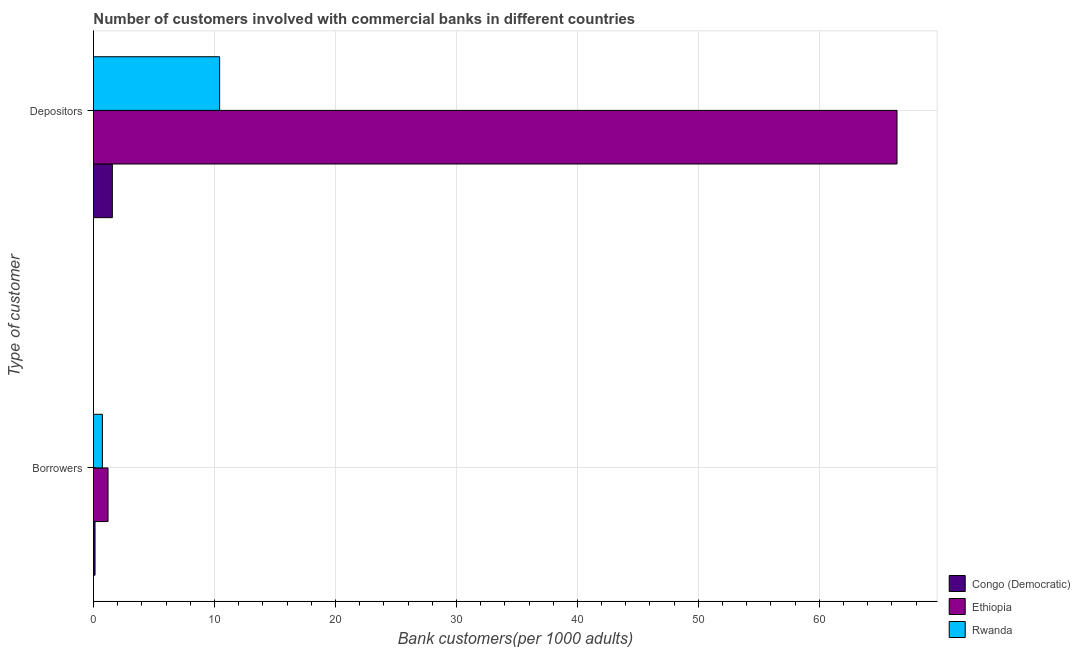How many different coloured bars are there?
Your response must be concise. 3. How many groups of bars are there?
Provide a short and direct response. 2. How many bars are there on the 2nd tick from the top?
Your answer should be compact. 3. What is the label of the 1st group of bars from the top?
Provide a succinct answer. Depositors. What is the number of depositors in Rwanda?
Your answer should be very brief. 10.43. Across all countries, what is the maximum number of depositors?
Your answer should be very brief. 66.42. Across all countries, what is the minimum number of borrowers?
Your answer should be very brief. 0.13. In which country was the number of depositors maximum?
Give a very brief answer. Ethiopia. In which country was the number of depositors minimum?
Your answer should be compact. Congo (Democratic). What is the total number of borrowers in the graph?
Your response must be concise. 2.07. What is the difference between the number of depositors in Ethiopia and that in Congo (Democratic)?
Make the answer very short. 64.86. What is the difference between the number of borrowers in Ethiopia and the number of depositors in Rwanda?
Give a very brief answer. -9.22. What is the average number of depositors per country?
Give a very brief answer. 26.14. What is the difference between the number of depositors and number of borrowers in Ethiopia?
Give a very brief answer. 65.21. What is the ratio of the number of depositors in Rwanda to that in Congo (Democratic)?
Your response must be concise. 6.68. Is the number of borrowers in Ethiopia less than that in Rwanda?
Offer a terse response. No. What does the 3rd bar from the top in Depositors represents?
Provide a short and direct response. Congo (Democratic). What does the 3rd bar from the bottom in Depositors represents?
Your answer should be compact. Rwanda. How many bars are there?
Ensure brevity in your answer.  6. Are all the bars in the graph horizontal?
Your response must be concise. Yes. How many countries are there in the graph?
Provide a short and direct response. 3. What is the difference between two consecutive major ticks on the X-axis?
Offer a terse response. 10. Are the values on the major ticks of X-axis written in scientific E-notation?
Provide a short and direct response. No. What is the title of the graph?
Ensure brevity in your answer.  Number of customers involved with commercial banks in different countries. Does "Somalia" appear as one of the legend labels in the graph?
Your answer should be compact. No. What is the label or title of the X-axis?
Your answer should be very brief. Bank customers(per 1000 adults). What is the label or title of the Y-axis?
Provide a succinct answer. Type of customer. What is the Bank customers(per 1000 adults) of Congo (Democratic) in Borrowers?
Provide a succinct answer. 0.13. What is the Bank customers(per 1000 adults) of Ethiopia in Borrowers?
Offer a terse response. 1.21. What is the Bank customers(per 1000 adults) in Rwanda in Borrowers?
Ensure brevity in your answer.  0.74. What is the Bank customers(per 1000 adults) of Congo (Democratic) in Depositors?
Provide a succinct answer. 1.56. What is the Bank customers(per 1000 adults) in Ethiopia in Depositors?
Ensure brevity in your answer.  66.42. What is the Bank customers(per 1000 adults) in Rwanda in Depositors?
Ensure brevity in your answer.  10.43. Across all Type of customer, what is the maximum Bank customers(per 1000 adults) of Congo (Democratic)?
Give a very brief answer. 1.56. Across all Type of customer, what is the maximum Bank customers(per 1000 adults) in Ethiopia?
Offer a terse response. 66.42. Across all Type of customer, what is the maximum Bank customers(per 1000 adults) in Rwanda?
Give a very brief answer. 10.43. Across all Type of customer, what is the minimum Bank customers(per 1000 adults) of Congo (Democratic)?
Your answer should be compact. 0.13. Across all Type of customer, what is the minimum Bank customers(per 1000 adults) of Ethiopia?
Offer a very short reply. 1.21. Across all Type of customer, what is the minimum Bank customers(per 1000 adults) in Rwanda?
Your answer should be compact. 0.74. What is the total Bank customers(per 1000 adults) in Congo (Democratic) in the graph?
Ensure brevity in your answer.  1.69. What is the total Bank customers(per 1000 adults) in Ethiopia in the graph?
Make the answer very short. 67.62. What is the total Bank customers(per 1000 adults) in Rwanda in the graph?
Make the answer very short. 11.17. What is the difference between the Bank customers(per 1000 adults) in Congo (Democratic) in Borrowers and that in Depositors?
Your answer should be compact. -1.43. What is the difference between the Bank customers(per 1000 adults) in Ethiopia in Borrowers and that in Depositors?
Give a very brief answer. -65.21. What is the difference between the Bank customers(per 1000 adults) in Rwanda in Borrowers and that in Depositors?
Provide a short and direct response. -9.69. What is the difference between the Bank customers(per 1000 adults) of Congo (Democratic) in Borrowers and the Bank customers(per 1000 adults) of Ethiopia in Depositors?
Offer a very short reply. -66.29. What is the difference between the Bank customers(per 1000 adults) of Congo (Democratic) in Borrowers and the Bank customers(per 1000 adults) of Rwanda in Depositors?
Offer a terse response. -10.3. What is the difference between the Bank customers(per 1000 adults) in Ethiopia in Borrowers and the Bank customers(per 1000 adults) in Rwanda in Depositors?
Give a very brief answer. -9.22. What is the average Bank customers(per 1000 adults) of Congo (Democratic) per Type of customer?
Offer a very short reply. 0.85. What is the average Bank customers(per 1000 adults) of Ethiopia per Type of customer?
Keep it short and to the point. 33.81. What is the average Bank customers(per 1000 adults) in Rwanda per Type of customer?
Offer a very short reply. 5.58. What is the difference between the Bank customers(per 1000 adults) of Congo (Democratic) and Bank customers(per 1000 adults) of Ethiopia in Borrowers?
Ensure brevity in your answer.  -1.07. What is the difference between the Bank customers(per 1000 adults) of Congo (Democratic) and Bank customers(per 1000 adults) of Rwanda in Borrowers?
Provide a succinct answer. -0.61. What is the difference between the Bank customers(per 1000 adults) in Ethiopia and Bank customers(per 1000 adults) in Rwanda in Borrowers?
Your answer should be very brief. 0.47. What is the difference between the Bank customers(per 1000 adults) of Congo (Democratic) and Bank customers(per 1000 adults) of Ethiopia in Depositors?
Your response must be concise. -64.86. What is the difference between the Bank customers(per 1000 adults) in Congo (Democratic) and Bank customers(per 1000 adults) in Rwanda in Depositors?
Ensure brevity in your answer.  -8.87. What is the difference between the Bank customers(per 1000 adults) in Ethiopia and Bank customers(per 1000 adults) in Rwanda in Depositors?
Keep it short and to the point. 55.99. What is the ratio of the Bank customers(per 1000 adults) of Congo (Democratic) in Borrowers to that in Depositors?
Your answer should be compact. 0.08. What is the ratio of the Bank customers(per 1000 adults) of Ethiopia in Borrowers to that in Depositors?
Provide a succinct answer. 0.02. What is the ratio of the Bank customers(per 1000 adults) in Rwanda in Borrowers to that in Depositors?
Make the answer very short. 0.07. What is the difference between the highest and the second highest Bank customers(per 1000 adults) of Congo (Democratic)?
Your response must be concise. 1.43. What is the difference between the highest and the second highest Bank customers(per 1000 adults) of Ethiopia?
Keep it short and to the point. 65.21. What is the difference between the highest and the second highest Bank customers(per 1000 adults) of Rwanda?
Ensure brevity in your answer.  9.69. What is the difference between the highest and the lowest Bank customers(per 1000 adults) in Congo (Democratic)?
Your response must be concise. 1.43. What is the difference between the highest and the lowest Bank customers(per 1000 adults) of Ethiopia?
Offer a terse response. 65.21. What is the difference between the highest and the lowest Bank customers(per 1000 adults) of Rwanda?
Make the answer very short. 9.69. 